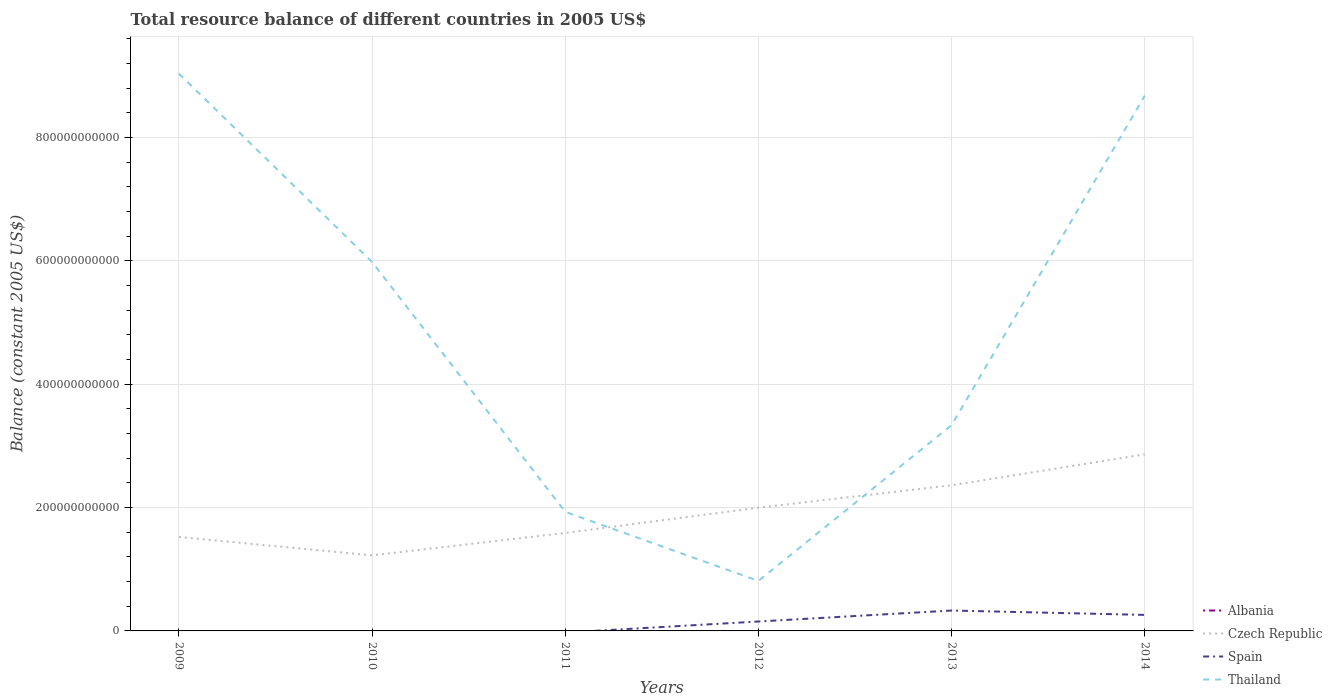How many different coloured lines are there?
Give a very brief answer. 3. Is the number of lines equal to the number of legend labels?
Make the answer very short. No. Across all years, what is the maximum total resource balance in Thailand?
Give a very brief answer. 8.11e+1. What is the total total resource balance in Czech Republic in the graph?
Make the answer very short. -1.64e+11. What is the difference between the highest and the second highest total resource balance in Spain?
Ensure brevity in your answer.  3.31e+1. What is the difference between the highest and the lowest total resource balance in Spain?
Offer a very short reply. 3. How many lines are there?
Provide a succinct answer. 3. How many years are there in the graph?
Give a very brief answer. 6. What is the difference between two consecutive major ticks on the Y-axis?
Your response must be concise. 2.00e+11. How are the legend labels stacked?
Offer a very short reply. Vertical. What is the title of the graph?
Your answer should be very brief. Total resource balance of different countries in 2005 US$. What is the label or title of the X-axis?
Offer a terse response. Years. What is the label or title of the Y-axis?
Your response must be concise. Balance (constant 2005 US$). What is the Balance (constant 2005 US$) in Albania in 2009?
Offer a very short reply. 0. What is the Balance (constant 2005 US$) of Czech Republic in 2009?
Provide a short and direct response. 1.52e+11. What is the Balance (constant 2005 US$) in Thailand in 2009?
Your answer should be very brief. 9.04e+11. What is the Balance (constant 2005 US$) of Czech Republic in 2010?
Offer a very short reply. 1.23e+11. What is the Balance (constant 2005 US$) of Spain in 2010?
Give a very brief answer. 0. What is the Balance (constant 2005 US$) of Thailand in 2010?
Your answer should be compact. 5.98e+11. What is the Balance (constant 2005 US$) in Albania in 2011?
Your answer should be very brief. 0. What is the Balance (constant 2005 US$) of Czech Republic in 2011?
Your answer should be compact. 1.59e+11. What is the Balance (constant 2005 US$) in Thailand in 2011?
Your response must be concise. 1.93e+11. What is the Balance (constant 2005 US$) of Albania in 2012?
Your answer should be compact. 0. What is the Balance (constant 2005 US$) in Czech Republic in 2012?
Provide a short and direct response. 2.00e+11. What is the Balance (constant 2005 US$) of Spain in 2012?
Your answer should be very brief. 1.53e+1. What is the Balance (constant 2005 US$) in Thailand in 2012?
Your answer should be very brief. 8.11e+1. What is the Balance (constant 2005 US$) of Albania in 2013?
Give a very brief answer. 0. What is the Balance (constant 2005 US$) of Czech Republic in 2013?
Provide a succinct answer. 2.36e+11. What is the Balance (constant 2005 US$) of Spain in 2013?
Make the answer very short. 3.31e+1. What is the Balance (constant 2005 US$) in Thailand in 2013?
Your answer should be compact. 3.34e+11. What is the Balance (constant 2005 US$) of Albania in 2014?
Keep it short and to the point. 0. What is the Balance (constant 2005 US$) of Czech Republic in 2014?
Keep it short and to the point. 2.86e+11. What is the Balance (constant 2005 US$) of Spain in 2014?
Keep it short and to the point. 2.60e+1. What is the Balance (constant 2005 US$) of Thailand in 2014?
Your response must be concise. 8.68e+11. Across all years, what is the maximum Balance (constant 2005 US$) of Czech Republic?
Offer a very short reply. 2.86e+11. Across all years, what is the maximum Balance (constant 2005 US$) in Spain?
Make the answer very short. 3.31e+1. Across all years, what is the maximum Balance (constant 2005 US$) in Thailand?
Provide a short and direct response. 9.04e+11. Across all years, what is the minimum Balance (constant 2005 US$) in Czech Republic?
Ensure brevity in your answer.  1.23e+11. Across all years, what is the minimum Balance (constant 2005 US$) in Spain?
Offer a terse response. 0. Across all years, what is the minimum Balance (constant 2005 US$) in Thailand?
Your response must be concise. 8.11e+1. What is the total Balance (constant 2005 US$) in Czech Republic in the graph?
Offer a very short reply. 1.16e+12. What is the total Balance (constant 2005 US$) in Spain in the graph?
Provide a succinct answer. 7.43e+1. What is the total Balance (constant 2005 US$) in Thailand in the graph?
Make the answer very short. 2.98e+12. What is the difference between the Balance (constant 2005 US$) in Czech Republic in 2009 and that in 2010?
Offer a very short reply. 2.98e+1. What is the difference between the Balance (constant 2005 US$) of Thailand in 2009 and that in 2010?
Provide a short and direct response. 3.05e+11. What is the difference between the Balance (constant 2005 US$) in Czech Republic in 2009 and that in 2011?
Provide a succinct answer. -6.51e+09. What is the difference between the Balance (constant 2005 US$) in Thailand in 2009 and that in 2011?
Make the answer very short. 7.11e+11. What is the difference between the Balance (constant 2005 US$) of Czech Republic in 2009 and that in 2012?
Provide a short and direct response. -4.75e+1. What is the difference between the Balance (constant 2005 US$) of Thailand in 2009 and that in 2012?
Your response must be concise. 8.23e+11. What is the difference between the Balance (constant 2005 US$) in Czech Republic in 2009 and that in 2013?
Your answer should be compact. -8.39e+1. What is the difference between the Balance (constant 2005 US$) of Thailand in 2009 and that in 2013?
Keep it short and to the point. 5.70e+11. What is the difference between the Balance (constant 2005 US$) in Czech Republic in 2009 and that in 2014?
Your answer should be very brief. -1.34e+11. What is the difference between the Balance (constant 2005 US$) in Thailand in 2009 and that in 2014?
Your response must be concise. 3.58e+1. What is the difference between the Balance (constant 2005 US$) of Czech Republic in 2010 and that in 2011?
Ensure brevity in your answer.  -3.63e+1. What is the difference between the Balance (constant 2005 US$) of Thailand in 2010 and that in 2011?
Give a very brief answer. 4.05e+11. What is the difference between the Balance (constant 2005 US$) in Czech Republic in 2010 and that in 2012?
Offer a terse response. -7.73e+1. What is the difference between the Balance (constant 2005 US$) in Thailand in 2010 and that in 2012?
Your answer should be compact. 5.17e+11. What is the difference between the Balance (constant 2005 US$) of Czech Republic in 2010 and that in 2013?
Ensure brevity in your answer.  -1.14e+11. What is the difference between the Balance (constant 2005 US$) of Thailand in 2010 and that in 2013?
Make the answer very short. 2.65e+11. What is the difference between the Balance (constant 2005 US$) in Czech Republic in 2010 and that in 2014?
Your answer should be compact. -1.64e+11. What is the difference between the Balance (constant 2005 US$) in Thailand in 2010 and that in 2014?
Your answer should be very brief. -2.70e+11. What is the difference between the Balance (constant 2005 US$) in Czech Republic in 2011 and that in 2012?
Offer a very short reply. -4.09e+1. What is the difference between the Balance (constant 2005 US$) in Thailand in 2011 and that in 2012?
Offer a very short reply. 1.12e+11. What is the difference between the Balance (constant 2005 US$) of Czech Republic in 2011 and that in 2013?
Offer a terse response. -7.74e+1. What is the difference between the Balance (constant 2005 US$) in Thailand in 2011 and that in 2013?
Your response must be concise. -1.41e+11. What is the difference between the Balance (constant 2005 US$) in Czech Republic in 2011 and that in 2014?
Offer a terse response. -1.27e+11. What is the difference between the Balance (constant 2005 US$) of Thailand in 2011 and that in 2014?
Offer a very short reply. -6.75e+11. What is the difference between the Balance (constant 2005 US$) in Czech Republic in 2012 and that in 2013?
Your response must be concise. -3.64e+1. What is the difference between the Balance (constant 2005 US$) in Spain in 2012 and that in 2013?
Give a very brief answer. -1.78e+1. What is the difference between the Balance (constant 2005 US$) of Thailand in 2012 and that in 2013?
Offer a very short reply. -2.53e+11. What is the difference between the Balance (constant 2005 US$) in Czech Republic in 2012 and that in 2014?
Offer a terse response. -8.65e+1. What is the difference between the Balance (constant 2005 US$) in Spain in 2012 and that in 2014?
Your response must be concise. -1.07e+1. What is the difference between the Balance (constant 2005 US$) in Thailand in 2012 and that in 2014?
Give a very brief answer. -7.87e+11. What is the difference between the Balance (constant 2005 US$) of Czech Republic in 2013 and that in 2014?
Ensure brevity in your answer.  -5.01e+1. What is the difference between the Balance (constant 2005 US$) in Spain in 2013 and that in 2014?
Provide a succinct answer. 7.09e+09. What is the difference between the Balance (constant 2005 US$) of Thailand in 2013 and that in 2014?
Ensure brevity in your answer.  -5.34e+11. What is the difference between the Balance (constant 2005 US$) of Czech Republic in 2009 and the Balance (constant 2005 US$) of Thailand in 2010?
Offer a terse response. -4.46e+11. What is the difference between the Balance (constant 2005 US$) in Czech Republic in 2009 and the Balance (constant 2005 US$) in Thailand in 2011?
Your answer should be very brief. -4.08e+1. What is the difference between the Balance (constant 2005 US$) in Czech Republic in 2009 and the Balance (constant 2005 US$) in Spain in 2012?
Your response must be concise. 1.37e+11. What is the difference between the Balance (constant 2005 US$) in Czech Republic in 2009 and the Balance (constant 2005 US$) in Thailand in 2012?
Offer a very short reply. 7.12e+1. What is the difference between the Balance (constant 2005 US$) in Czech Republic in 2009 and the Balance (constant 2005 US$) in Spain in 2013?
Your answer should be compact. 1.19e+11. What is the difference between the Balance (constant 2005 US$) of Czech Republic in 2009 and the Balance (constant 2005 US$) of Thailand in 2013?
Keep it short and to the point. -1.81e+11. What is the difference between the Balance (constant 2005 US$) of Czech Republic in 2009 and the Balance (constant 2005 US$) of Spain in 2014?
Ensure brevity in your answer.  1.26e+11. What is the difference between the Balance (constant 2005 US$) of Czech Republic in 2009 and the Balance (constant 2005 US$) of Thailand in 2014?
Ensure brevity in your answer.  -7.16e+11. What is the difference between the Balance (constant 2005 US$) of Czech Republic in 2010 and the Balance (constant 2005 US$) of Thailand in 2011?
Your answer should be very brief. -7.06e+1. What is the difference between the Balance (constant 2005 US$) in Czech Republic in 2010 and the Balance (constant 2005 US$) in Spain in 2012?
Ensure brevity in your answer.  1.07e+11. What is the difference between the Balance (constant 2005 US$) in Czech Republic in 2010 and the Balance (constant 2005 US$) in Thailand in 2012?
Provide a short and direct response. 4.14e+1. What is the difference between the Balance (constant 2005 US$) of Czech Republic in 2010 and the Balance (constant 2005 US$) of Spain in 2013?
Your answer should be compact. 8.95e+1. What is the difference between the Balance (constant 2005 US$) in Czech Republic in 2010 and the Balance (constant 2005 US$) in Thailand in 2013?
Your answer should be very brief. -2.11e+11. What is the difference between the Balance (constant 2005 US$) in Czech Republic in 2010 and the Balance (constant 2005 US$) in Spain in 2014?
Provide a short and direct response. 9.65e+1. What is the difference between the Balance (constant 2005 US$) in Czech Republic in 2010 and the Balance (constant 2005 US$) in Thailand in 2014?
Make the answer very short. -7.45e+11. What is the difference between the Balance (constant 2005 US$) in Czech Republic in 2011 and the Balance (constant 2005 US$) in Spain in 2012?
Keep it short and to the point. 1.44e+11. What is the difference between the Balance (constant 2005 US$) in Czech Republic in 2011 and the Balance (constant 2005 US$) in Thailand in 2012?
Your answer should be compact. 7.77e+1. What is the difference between the Balance (constant 2005 US$) in Czech Republic in 2011 and the Balance (constant 2005 US$) in Spain in 2013?
Offer a very short reply. 1.26e+11. What is the difference between the Balance (constant 2005 US$) in Czech Republic in 2011 and the Balance (constant 2005 US$) in Thailand in 2013?
Offer a terse response. -1.75e+11. What is the difference between the Balance (constant 2005 US$) in Czech Republic in 2011 and the Balance (constant 2005 US$) in Spain in 2014?
Your answer should be compact. 1.33e+11. What is the difference between the Balance (constant 2005 US$) in Czech Republic in 2011 and the Balance (constant 2005 US$) in Thailand in 2014?
Provide a succinct answer. -7.09e+11. What is the difference between the Balance (constant 2005 US$) of Czech Republic in 2012 and the Balance (constant 2005 US$) of Spain in 2013?
Give a very brief answer. 1.67e+11. What is the difference between the Balance (constant 2005 US$) of Czech Republic in 2012 and the Balance (constant 2005 US$) of Thailand in 2013?
Your answer should be compact. -1.34e+11. What is the difference between the Balance (constant 2005 US$) of Spain in 2012 and the Balance (constant 2005 US$) of Thailand in 2013?
Keep it short and to the point. -3.18e+11. What is the difference between the Balance (constant 2005 US$) in Czech Republic in 2012 and the Balance (constant 2005 US$) in Spain in 2014?
Offer a terse response. 1.74e+11. What is the difference between the Balance (constant 2005 US$) of Czech Republic in 2012 and the Balance (constant 2005 US$) of Thailand in 2014?
Offer a very short reply. -6.68e+11. What is the difference between the Balance (constant 2005 US$) in Spain in 2012 and the Balance (constant 2005 US$) in Thailand in 2014?
Provide a short and direct response. -8.53e+11. What is the difference between the Balance (constant 2005 US$) in Czech Republic in 2013 and the Balance (constant 2005 US$) in Spain in 2014?
Make the answer very short. 2.10e+11. What is the difference between the Balance (constant 2005 US$) of Czech Republic in 2013 and the Balance (constant 2005 US$) of Thailand in 2014?
Offer a terse response. -6.32e+11. What is the difference between the Balance (constant 2005 US$) in Spain in 2013 and the Balance (constant 2005 US$) in Thailand in 2014?
Offer a terse response. -8.35e+11. What is the average Balance (constant 2005 US$) of Albania per year?
Give a very brief answer. 0. What is the average Balance (constant 2005 US$) of Czech Republic per year?
Ensure brevity in your answer.  1.93e+11. What is the average Balance (constant 2005 US$) of Spain per year?
Make the answer very short. 1.24e+1. What is the average Balance (constant 2005 US$) in Thailand per year?
Give a very brief answer. 4.96e+11. In the year 2009, what is the difference between the Balance (constant 2005 US$) of Czech Republic and Balance (constant 2005 US$) of Thailand?
Make the answer very short. -7.51e+11. In the year 2010, what is the difference between the Balance (constant 2005 US$) of Czech Republic and Balance (constant 2005 US$) of Thailand?
Ensure brevity in your answer.  -4.76e+11. In the year 2011, what is the difference between the Balance (constant 2005 US$) in Czech Republic and Balance (constant 2005 US$) in Thailand?
Offer a terse response. -3.42e+1. In the year 2012, what is the difference between the Balance (constant 2005 US$) in Czech Republic and Balance (constant 2005 US$) in Spain?
Your response must be concise. 1.85e+11. In the year 2012, what is the difference between the Balance (constant 2005 US$) in Czech Republic and Balance (constant 2005 US$) in Thailand?
Ensure brevity in your answer.  1.19e+11. In the year 2012, what is the difference between the Balance (constant 2005 US$) in Spain and Balance (constant 2005 US$) in Thailand?
Your answer should be compact. -6.58e+1. In the year 2013, what is the difference between the Balance (constant 2005 US$) in Czech Republic and Balance (constant 2005 US$) in Spain?
Give a very brief answer. 2.03e+11. In the year 2013, what is the difference between the Balance (constant 2005 US$) in Czech Republic and Balance (constant 2005 US$) in Thailand?
Your answer should be very brief. -9.75e+1. In the year 2013, what is the difference between the Balance (constant 2005 US$) of Spain and Balance (constant 2005 US$) of Thailand?
Keep it short and to the point. -3.01e+11. In the year 2014, what is the difference between the Balance (constant 2005 US$) of Czech Republic and Balance (constant 2005 US$) of Spain?
Offer a very short reply. 2.60e+11. In the year 2014, what is the difference between the Balance (constant 2005 US$) in Czech Republic and Balance (constant 2005 US$) in Thailand?
Your response must be concise. -5.82e+11. In the year 2014, what is the difference between the Balance (constant 2005 US$) in Spain and Balance (constant 2005 US$) in Thailand?
Provide a succinct answer. -8.42e+11. What is the ratio of the Balance (constant 2005 US$) in Czech Republic in 2009 to that in 2010?
Make the answer very short. 1.24. What is the ratio of the Balance (constant 2005 US$) in Thailand in 2009 to that in 2010?
Your answer should be compact. 1.51. What is the ratio of the Balance (constant 2005 US$) in Thailand in 2009 to that in 2011?
Make the answer very short. 4.68. What is the ratio of the Balance (constant 2005 US$) in Czech Republic in 2009 to that in 2012?
Ensure brevity in your answer.  0.76. What is the ratio of the Balance (constant 2005 US$) of Thailand in 2009 to that in 2012?
Keep it short and to the point. 11.14. What is the ratio of the Balance (constant 2005 US$) of Czech Republic in 2009 to that in 2013?
Ensure brevity in your answer.  0.64. What is the ratio of the Balance (constant 2005 US$) of Thailand in 2009 to that in 2013?
Offer a very short reply. 2.71. What is the ratio of the Balance (constant 2005 US$) in Czech Republic in 2009 to that in 2014?
Provide a short and direct response. 0.53. What is the ratio of the Balance (constant 2005 US$) in Thailand in 2009 to that in 2014?
Provide a short and direct response. 1.04. What is the ratio of the Balance (constant 2005 US$) of Czech Republic in 2010 to that in 2011?
Offer a very short reply. 0.77. What is the ratio of the Balance (constant 2005 US$) of Thailand in 2010 to that in 2011?
Provide a short and direct response. 3.1. What is the ratio of the Balance (constant 2005 US$) in Czech Republic in 2010 to that in 2012?
Ensure brevity in your answer.  0.61. What is the ratio of the Balance (constant 2005 US$) of Thailand in 2010 to that in 2012?
Ensure brevity in your answer.  7.38. What is the ratio of the Balance (constant 2005 US$) in Czech Republic in 2010 to that in 2013?
Offer a very short reply. 0.52. What is the ratio of the Balance (constant 2005 US$) of Thailand in 2010 to that in 2013?
Ensure brevity in your answer.  1.79. What is the ratio of the Balance (constant 2005 US$) of Czech Republic in 2010 to that in 2014?
Make the answer very short. 0.43. What is the ratio of the Balance (constant 2005 US$) in Thailand in 2010 to that in 2014?
Your response must be concise. 0.69. What is the ratio of the Balance (constant 2005 US$) of Czech Republic in 2011 to that in 2012?
Provide a succinct answer. 0.8. What is the ratio of the Balance (constant 2005 US$) in Thailand in 2011 to that in 2012?
Offer a terse response. 2.38. What is the ratio of the Balance (constant 2005 US$) in Czech Republic in 2011 to that in 2013?
Offer a very short reply. 0.67. What is the ratio of the Balance (constant 2005 US$) of Thailand in 2011 to that in 2013?
Ensure brevity in your answer.  0.58. What is the ratio of the Balance (constant 2005 US$) in Czech Republic in 2011 to that in 2014?
Keep it short and to the point. 0.55. What is the ratio of the Balance (constant 2005 US$) in Thailand in 2011 to that in 2014?
Ensure brevity in your answer.  0.22. What is the ratio of the Balance (constant 2005 US$) of Czech Republic in 2012 to that in 2013?
Provide a short and direct response. 0.85. What is the ratio of the Balance (constant 2005 US$) in Spain in 2012 to that in 2013?
Provide a short and direct response. 0.46. What is the ratio of the Balance (constant 2005 US$) in Thailand in 2012 to that in 2013?
Your answer should be very brief. 0.24. What is the ratio of the Balance (constant 2005 US$) of Czech Republic in 2012 to that in 2014?
Provide a succinct answer. 0.7. What is the ratio of the Balance (constant 2005 US$) in Spain in 2012 to that in 2014?
Ensure brevity in your answer.  0.59. What is the ratio of the Balance (constant 2005 US$) of Thailand in 2012 to that in 2014?
Your answer should be compact. 0.09. What is the ratio of the Balance (constant 2005 US$) in Czech Republic in 2013 to that in 2014?
Offer a terse response. 0.82. What is the ratio of the Balance (constant 2005 US$) in Spain in 2013 to that in 2014?
Offer a very short reply. 1.27. What is the ratio of the Balance (constant 2005 US$) in Thailand in 2013 to that in 2014?
Keep it short and to the point. 0.38. What is the difference between the highest and the second highest Balance (constant 2005 US$) of Czech Republic?
Make the answer very short. 5.01e+1. What is the difference between the highest and the second highest Balance (constant 2005 US$) in Spain?
Your response must be concise. 7.09e+09. What is the difference between the highest and the second highest Balance (constant 2005 US$) of Thailand?
Make the answer very short. 3.58e+1. What is the difference between the highest and the lowest Balance (constant 2005 US$) in Czech Republic?
Offer a very short reply. 1.64e+11. What is the difference between the highest and the lowest Balance (constant 2005 US$) in Spain?
Offer a very short reply. 3.31e+1. What is the difference between the highest and the lowest Balance (constant 2005 US$) of Thailand?
Offer a very short reply. 8.23e+11. 